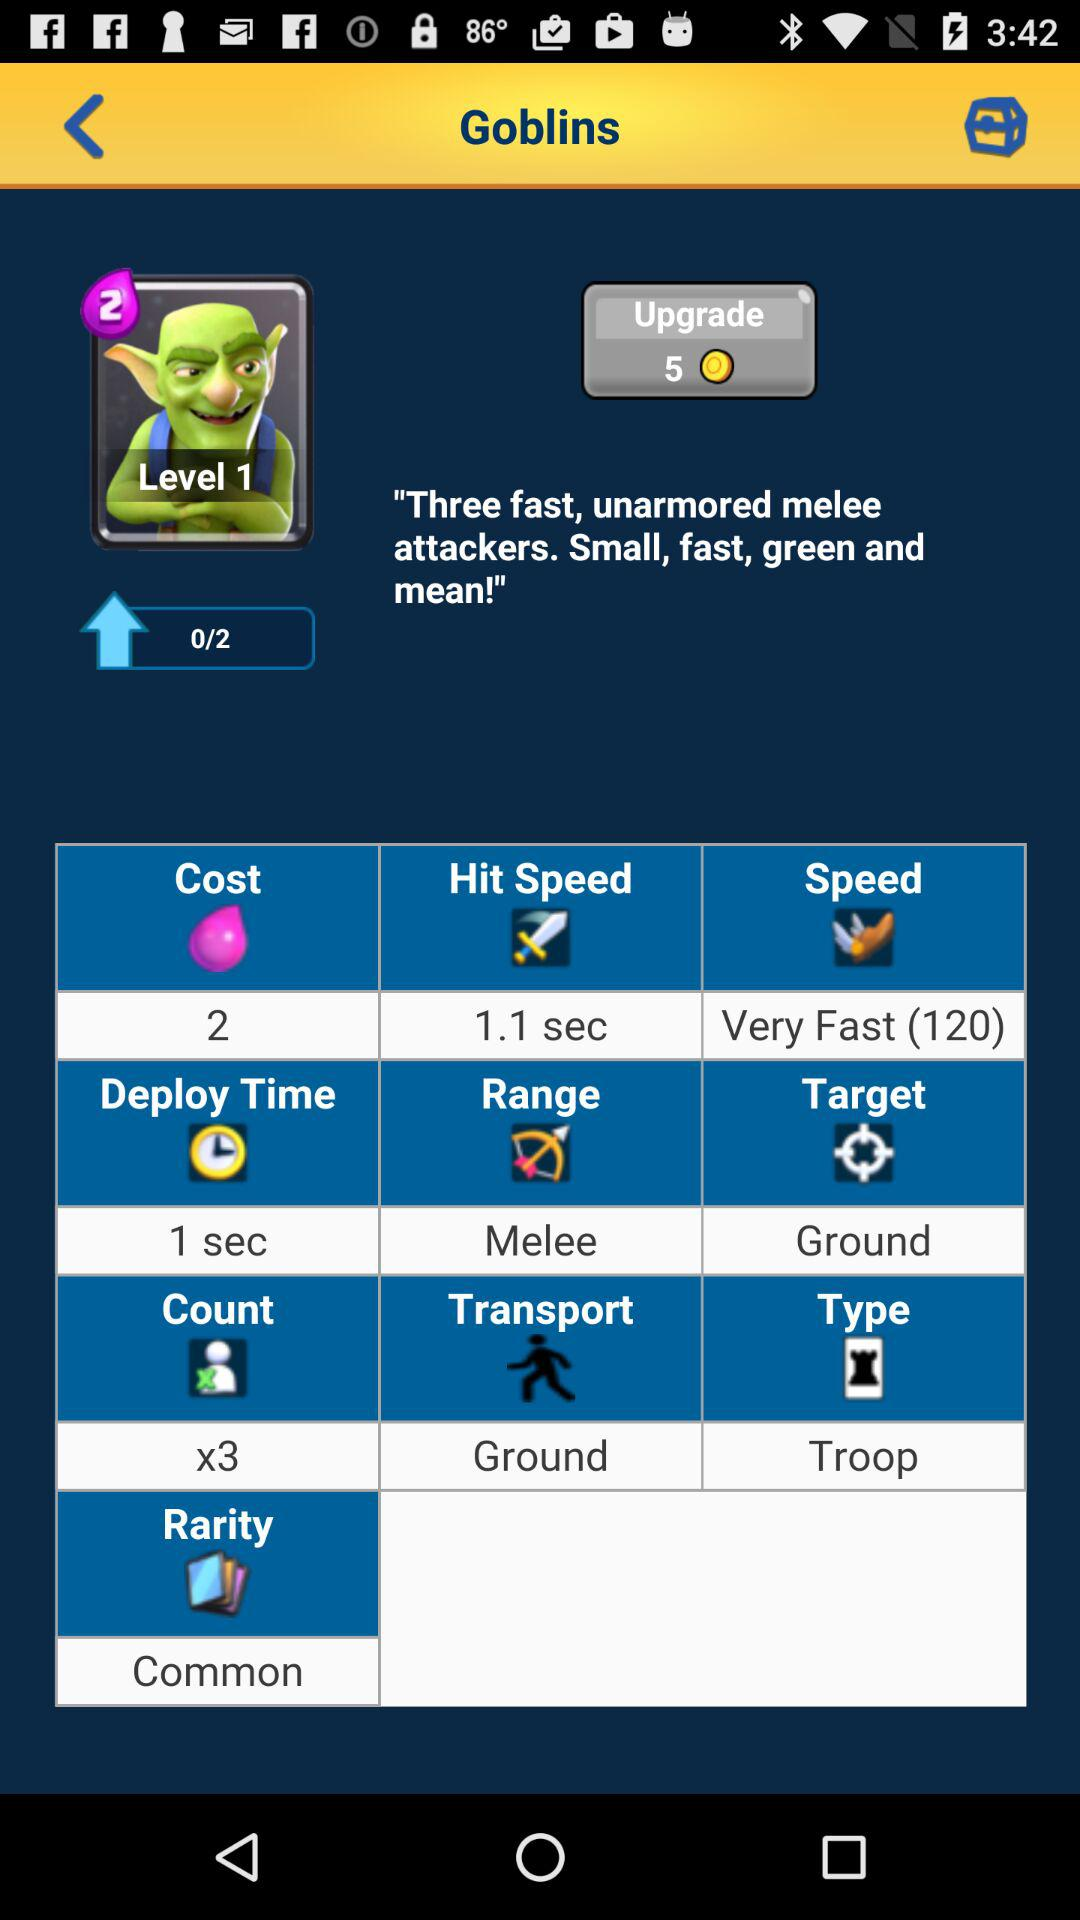What is the duration of "Deploy Time"? The duration is 1 second. 